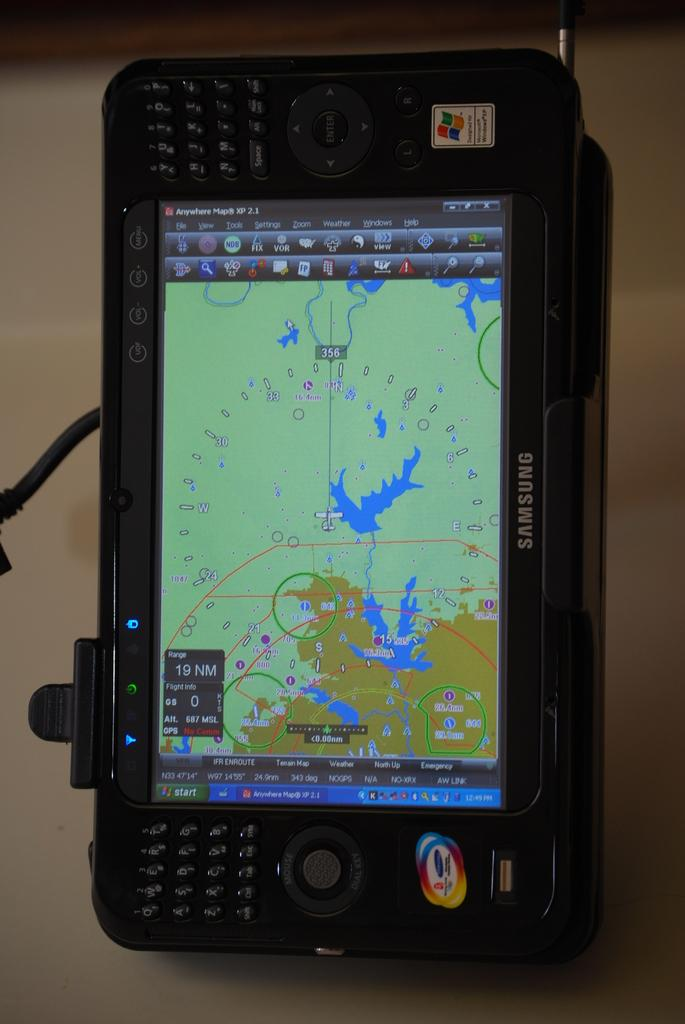<image>
Give a short and clear explanation of the subsequent image. a phone that has Samsung written at the bottom' 